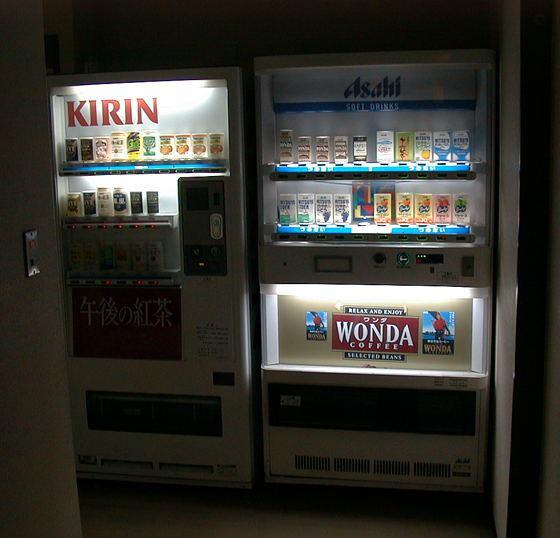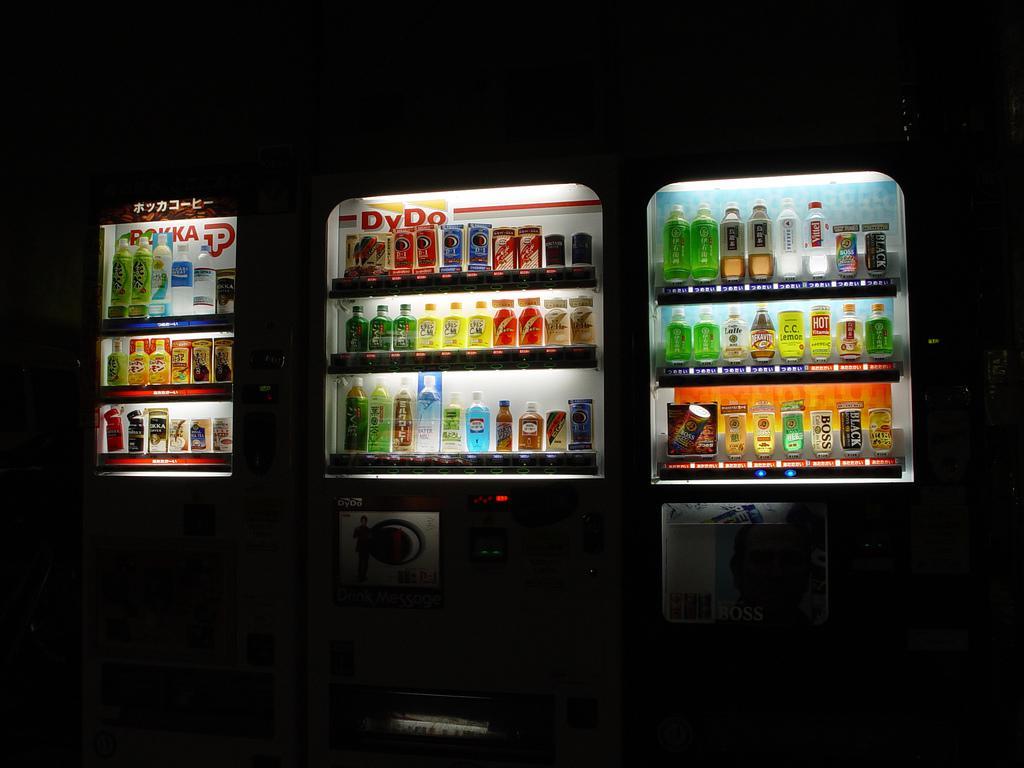The first image is the image on the left, the second image is the image on the right. Examine the images to the left and right. Is the description "There are no more than two vending machines in the image on the right." accurate? Answer yes or no. No. The first image is the image on the left, the second image is the image on the right. Given the left and right images, does the statement "None of the images show more than two vending machines." hold true? Answer yes or no. No. 